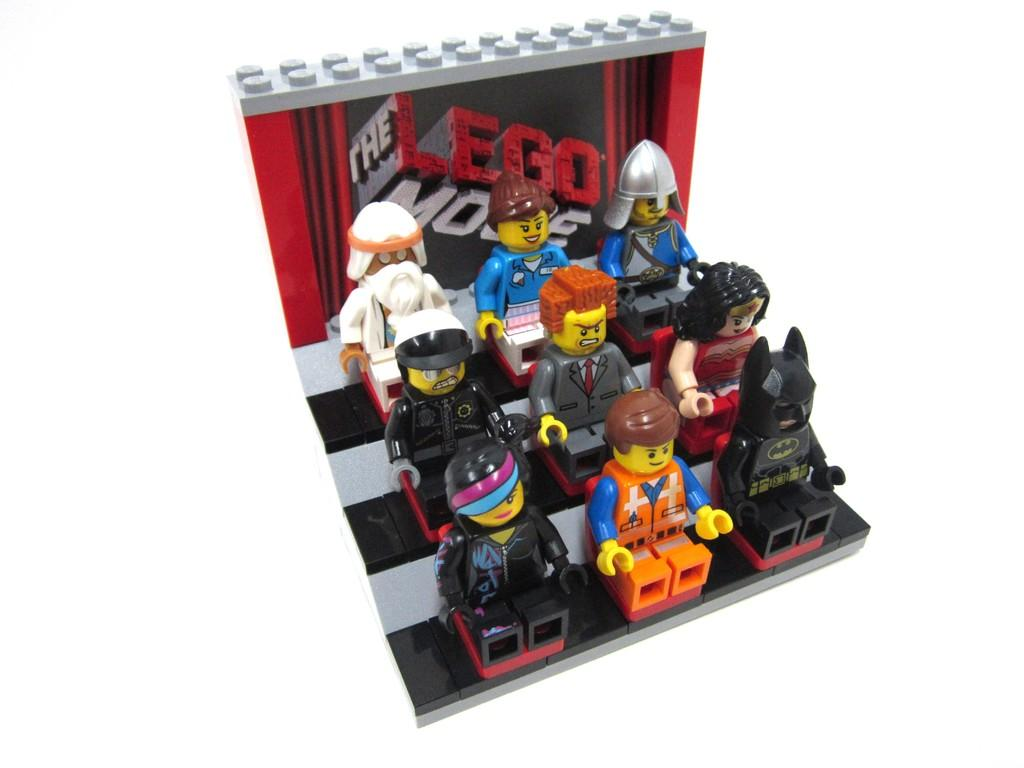What type of toys are visible in the image? There are LEGO toys in the image. What color is the background of the image? The background of the image is white. What type of whip is being used to play the game in the image? There is no whip or game present in the image; it only features LEGO toys. 